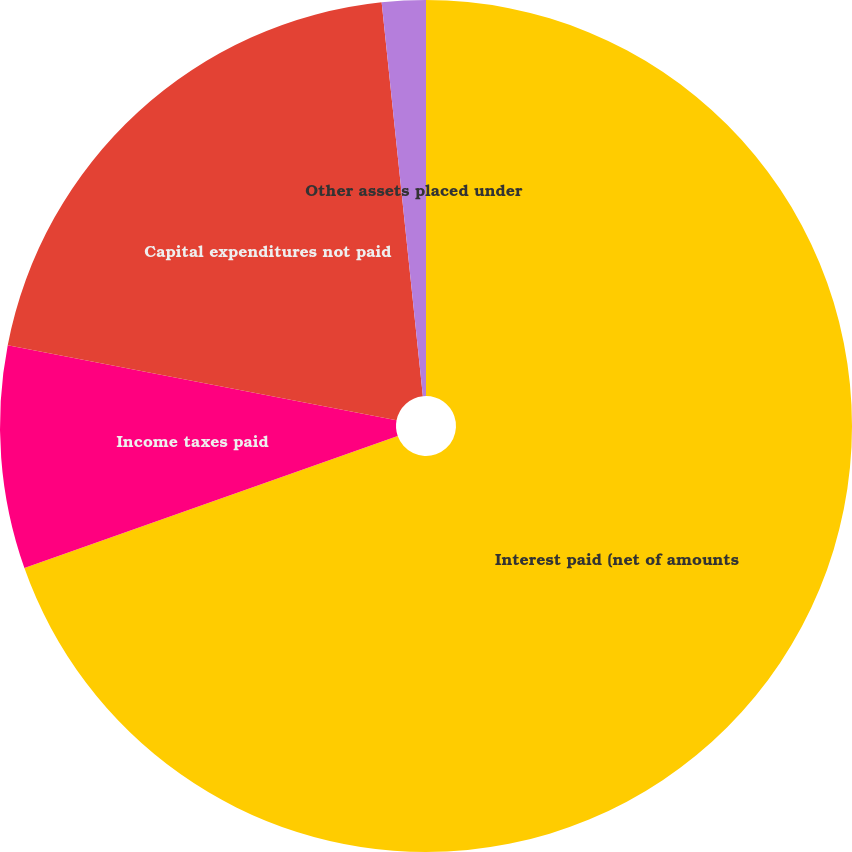<chart> <loc_0><loc_0><loc_500><loc_500><pie_chart><fcel>Interest paid (net of amounts<fcel>Income taxes paid<fcel>Capital expenditures not paid<fcel>Other assets placed under<nl><fcel>69.58%<fcel>8.45%<fcel>20.3%<fcel>1.66%<nl></chart> 